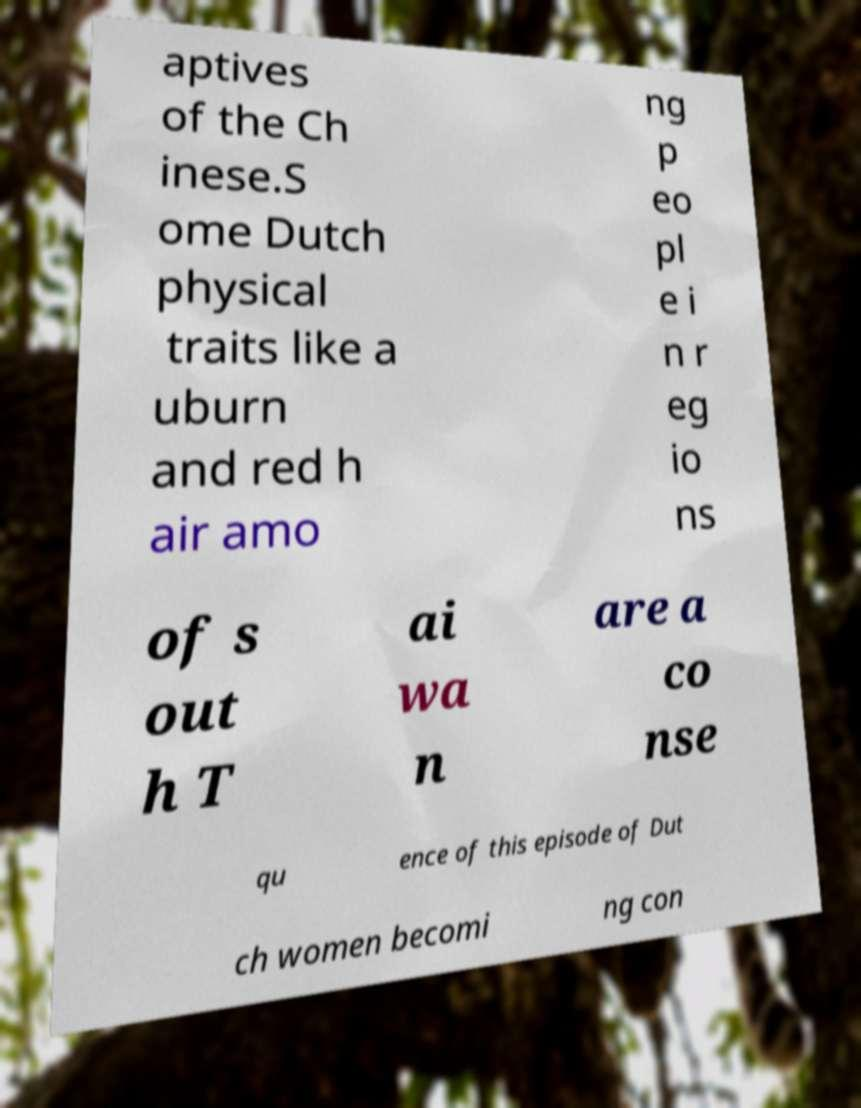Could you assist in decoding the text presented in this image and type it out clearly? aptives of the Ch inese.S ome Dutch physical traits like a uburn and red h air amo ng p eo pl e i n r eg io ns of s out h T ai wa n are a co nse qu ence of this episode of Dut ch women becomi ng con 